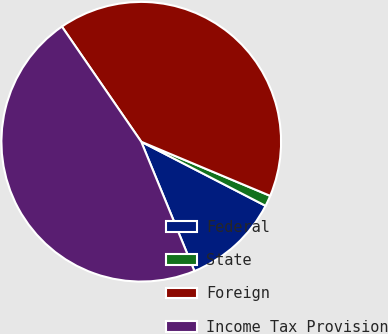Convert chart. <chart><loc_0><loc_0><loc_500><loc_500><pie_chart><fcel>Federal<fcel>State<fcel>Foreign<fcel>Income Tax Provision<nl><fcel>11.22%<fcel>1.25%<fcel>40.93%<fcel>46.61%<nl></chart> 